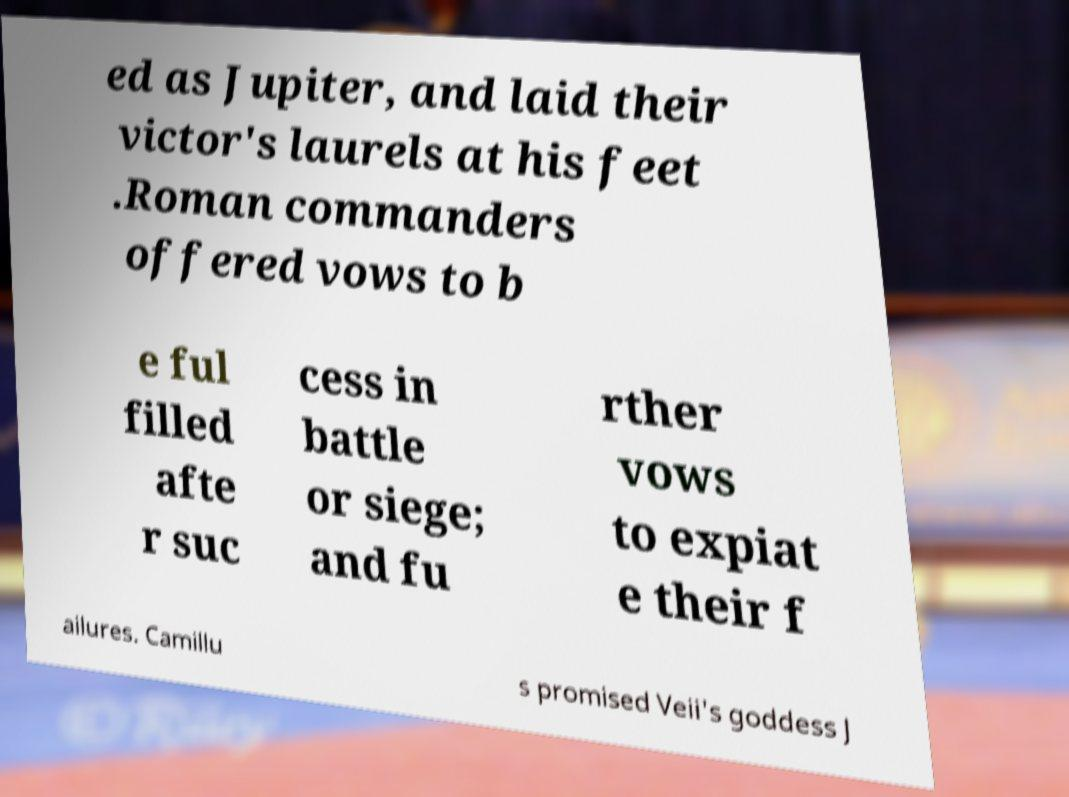Please identify and transcribe the text found in this image. ed as Jupiter, and laid their victor's laurels at his feet .Roman commanders offered vows to b e ful filled afte r suc cess in battle or siege; and fu rther vows to expiat e their f ailures. Camillu s promised Veii's goddess J 